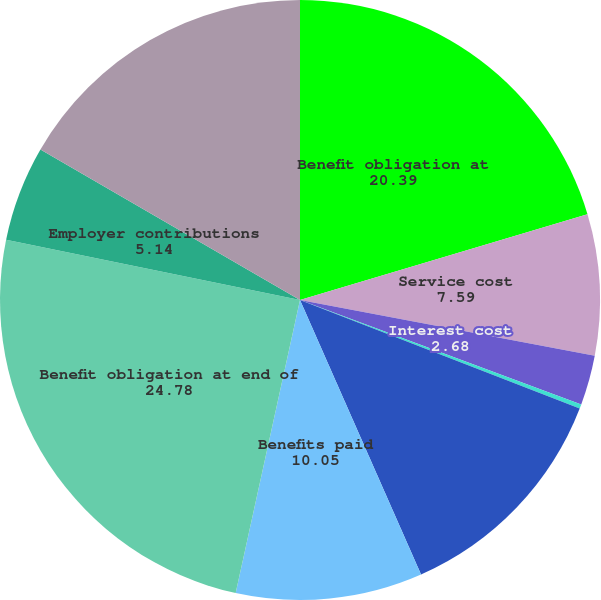<chart> <loc_0><loc_0><loc_500><loc_500><pie_chart><fcel>Benefit obligation at<fcel>Service cost<fcel>Interest cost<fcel>Participant contributions<fcel>Actuarial losses (gains)<fcel>Benefits paid<fcel>Benefit obligation at end of<fcel>Employer contributions<fcel>Funded status at end of year<nl><fcel>20.39%<fcel>7.59%<fcel>2.68%<fcel>0.23%<fcel>12.5%<fcel>10.05%<fcel>24.78%<fcel>5.14%<fcel>16.64%<nl></chart> 